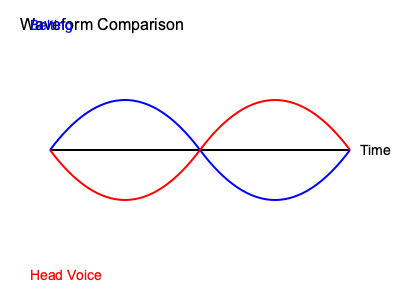In the waveform diagram above, which vocal technique is likely to produce a more powerful and projected sound, and why? To answer this question, let's analyze the waveform diagram step by step:

1. The diagram shows two waveforms: one in blue (top) and one in red (bottom).

2. The blue waveform has larger amplitude (height of the wave from the center line). This indicates:
   a. Greater sound intensity
   b. More vocal power
   c. Stronger resonance

3. The red waveform has smaller amplitude, suggesting:
   a. Less sound intensity
   b. More controlled and lighter vocal production

4. Based on these characteristics:
   - The blue waveform represents belting, a technique used in popular music for powerful, projected singing.
   - The red waveform represents head voice, typically used for higher, softer notes.

5. Belting (blue waveform) produces a more powerful sound because:
   a. It uses more vocal fold mass
   b. It creates stronger resonance in the vocal tract
   c. It engages more chest resonance

6. Head voice (red waveform) is generally softer because:
   a. It uses less vocal fold mass
   b. It relies more on head resonance
   c. It's often used for higher pitches where power is less emphasized

Therefore, the vocal technique likely to produce a more powerful and projected sound is belting, represented by the blue waveform with larger amplitude.
Answer: Belting (blue waveform) 